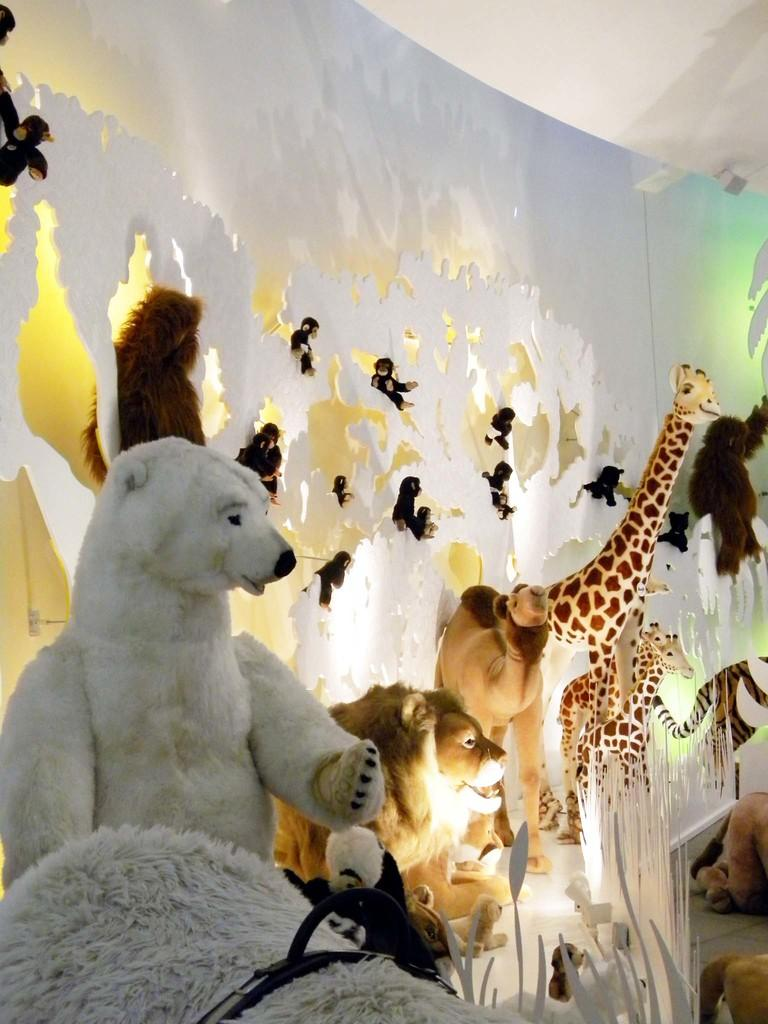What types of living organisms are shown in the image? There are animals depicted in the image. What can be seen in the background of the image? The wall is visible in the background of the image. What type of duck can be seen with a burnt nose in the image? There is no duck or any indication of a burnt nose present in the image. 